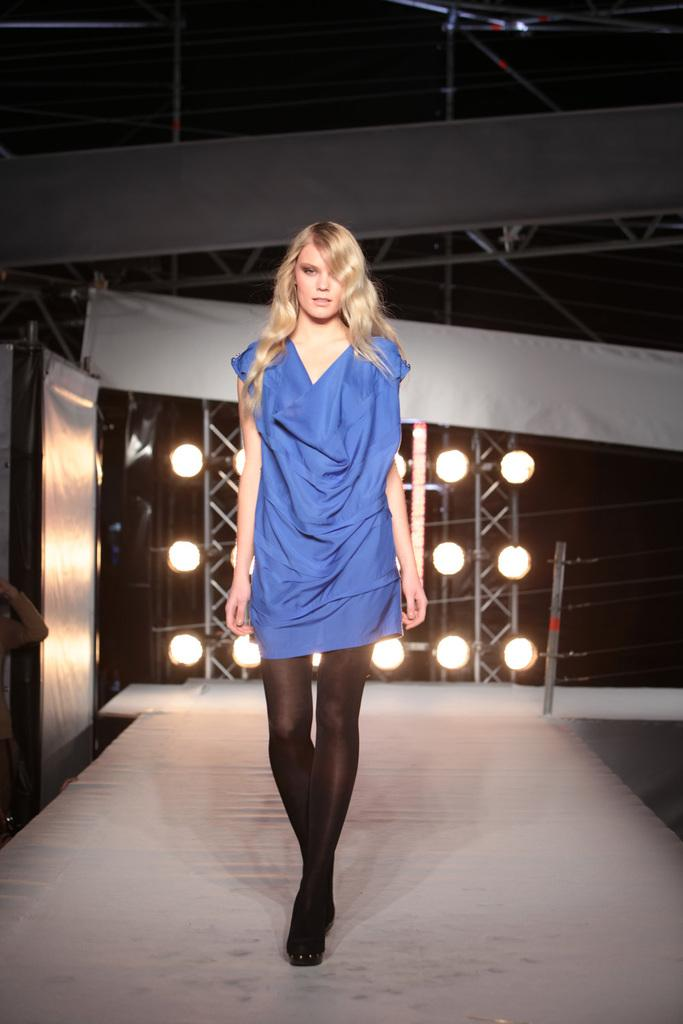Who is present in the image? There is a woman in the image. What is the surface beneath the woman? The image shows a floor. What can be seen in the background of the image? There are lights, poles, wires, and banners in the background of the image. Is there a cemetery visible in the image? No, there is no cemetery present in the image. 